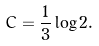<formula> <loc_0><loc_0><loc_500><loc_500>C = \frac { 1 } { 3 } \log 2 .</formula> 